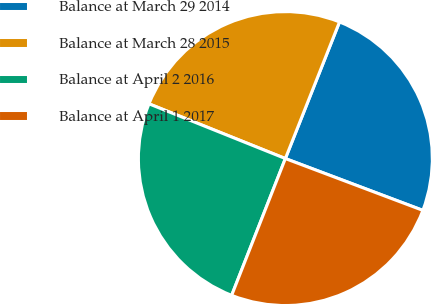<chart> <loc_0><loc_0><loc_500><loc_500><pie_chart><fcel>Balance at March 29 2014<fcel>Balance at March 28 2015<fcel>Balance at April 2 2016<fcel>Balance at April 1 2017<nl><fcel>24.73%<fcel>24.93%<fcel>25.12%<fcel>25.22%<nl></chart> 